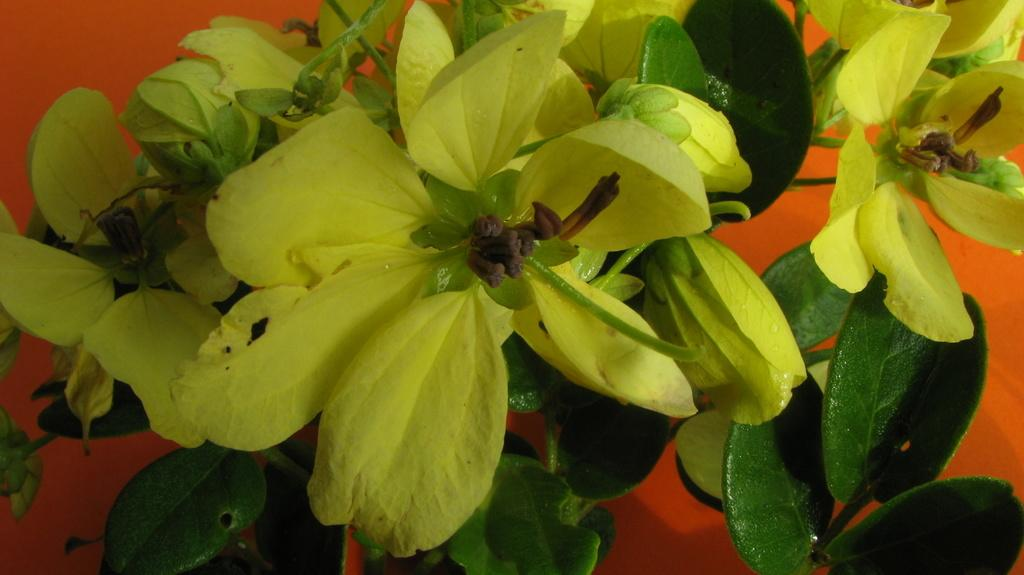What type of plant is visible in the image? There is a plant with flowers in the image. What color is the background of the image? The background of the image is orange. What type of vegetable is growing next to the plant in the image? There is no vegetable present in the image; it only features a plant with flowers. What action is being performed by the end of the image? The end is not an entity that can perform actions, as it is a concept rather than an object in the image. 